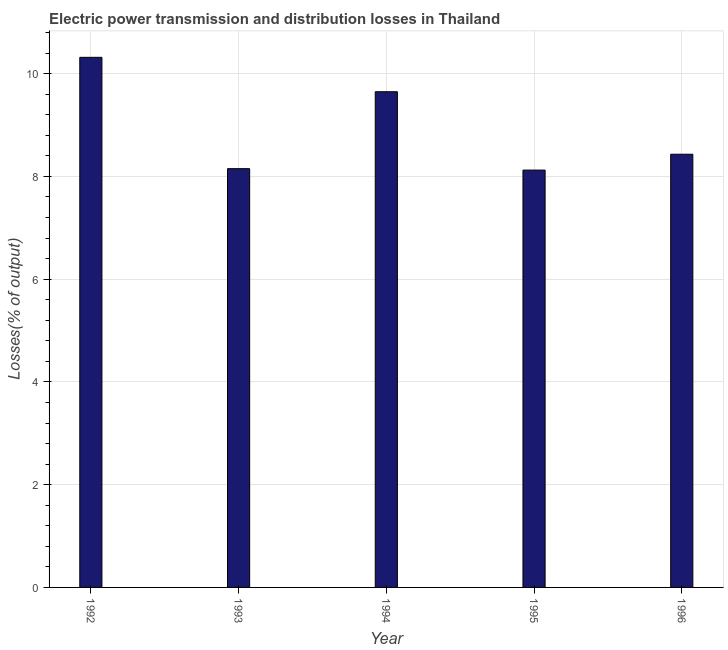Does the graph contain any zero values?
Provide a succinct answer. No. Does the graph contain grids?
Keep it short and to the point. Yes. What is the title of the graph?
Provide a short and direct response. Electric power transmission and distribution losses in Thailand. What is the label or title of the Y-axis?
Provide a short and direct response. Losses(% of output). What is the electric power transmission and distribution losses in 1996?
Your answer should be very brief. 8.43. Across all years, what is the maximum electric power transmission and distribution losses?
Offer a very short reply. 10.32. Across all years, what is the minimum electric power transmission and distribution losses?
Make the answer very short. 8.12. In which year was the electric power transmission and distribution losses minimum?
Ensure brevity in your answer.  1995. What is the sum of the electric power transmission and distribution losses?
Offer a terse response. 44.67. What is the difference between the electric power transmission and distribution losses in 1993 and 1996?
Offer a very short reply. -0.28. What is the average electric power transmission and distribution losses per year?
Provide a short and direct response. 8.93. What is the median electric power transmission and distribution losses?
Keep it short and to the point. 8.43. In how many years, is the electric power transmission and distribution losses greater than 0.8 %?
Make the answer very short. 5. What is the ratio of the electric power transmission and distribution losses in 1992 to that in 1993?
Make the answer very short. 1.27. Is the difference between the electric power transmission and distribution losses in 1994 and 1996 greater than the difference between any two years?
Keep it short and to the point. No. What is the difference between the highest and the second highest electric power transmission and distribution losses?
Give a very brief answer. 0.67. What is the difference between the highest and the lowest electric power transmission and distribution losses?
Offer a very short reply. 2.19. In how many years, is the electric power transmission and distribution losses greater than the average electric power transmission and distribution losses taken over all years?
Offer a terse response. 2. How many bars are there?
Ensure brevity in your answer.  5. What is the Losses(% of output) in 1992?
Make the answer very short. 10.32. What is the Losses(% of output) of 1993?
Your answer should be compact. 8.15. What is the Losses(% of output) of 1994?
Your answer should be very brief. 9.65. What is the Losses(% of output) in 1995?
Your answer should be compact. 8.12. What is the Losses(% of output) of 1996?
Your answer should be compact. 8.43. What is the difference between the Losses(% of output) in 1992 and 1993?
Offer a very short reply. 2.17. What is the difference between the Losses(% of output) in 1992 and 1994?
Make the answer very short. 0.67. What is the difference between the Losses(% of output) in 1992 and 1995?
Ensure brevity in your answer.  2.19. What is the difference between the Losses(% of output) in 1992 and 1996?
Provide a short and direct response. 1.89. What is the difference between the Losses(% of output) in 1993 and 1994?
Your response must be concise. -1.5. What is the difference between the Losses(% of output) in 1993 and 1995?
Your answer should be compact. 0.03. What is the difference between the Losses(% of output) in 1993 and 1996?
Offer a very short reply. -0.28. What is the difference between the Losses(% of output) in 1994 and 1995?
Provide a short and direct response. 1.52. What is the difference between the Losses(% of output) in 1994 and 1996?
Give a very brief answer. 1.22. What is the difference between the Losses(% of output) in 1995 and 1996?
Offer a very short reply. -0.31. What is the ratio of the Losses(% of output) in 1992 to that in 1993?
Your answer should be compact. 1.27. What is the ratio of the Losses(% of output) in 1992 to that in 1994?
Your answer should be compact. 1.07. What is the ratio of the Losses(% of output) in 1992 to that in 1995?
Give a very brief answer. 1.27. What is the ratio of the Losses(% of output) in 1992 to that in 1996?
Your response must be concise. 1.22. What is the ratio of the Losses(% of output) in 1993 to that in 1994?
Provide a short and direct response. 0.84. What is the ratio of the Losses(% of output) in 1993 to that in 1995?
Keep it short and to the point. 1. What is the ratio of the Losses(% of output) in 1993 to that in 1996?
Ensure brevity in your answer.  0.97. What is the ratio of the Losses(% of output) in 1994 to that in 1995?
Offer a very short reply. 1.19. What is the ratio of the Losses(% of output) in 1994 to that in 1996?
Ensure brevity in your answer.  1.14. 